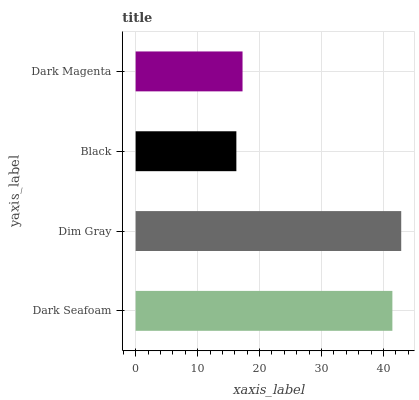Is Black the minimum?
Answer yes or no. Yes. Is Dim Gray the maximum?
Answer yes or no. Yes. Is Dim Gray the minimum?
Answer yes or no. No. Is Black the maximum?
Answer yes or no. No. Is Dim Gray greater than Black?
Answer yes or no. Yes. Is Black less than Dim Gray?
Answer yes or no. Yes. Is Black greater than Dim Gray?
Answer yes or no. No. Is Dim Gray less than Black?
Answer yes or no. No. Is Dark Seafoam the high median?
Answer yes or no. Yes. Is Dark Magenta the low median?
Answer yes or no. Yes. Is Black the high median?
Answer yes or no. No. Is Dim Gray the low median?
Answer yes or no. No. 